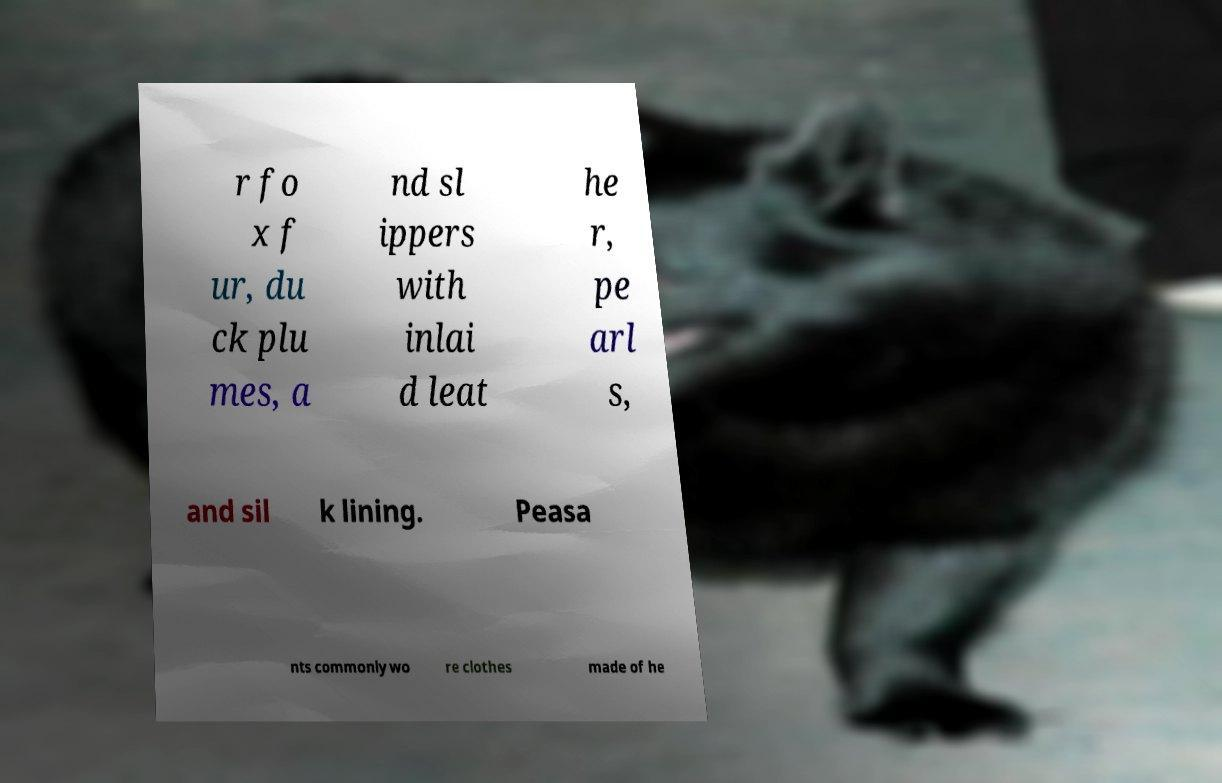Please identify and transcribe the text found in this image. r fo x f ur, du ck plu mes, a nd sl ippers with inlai d leat he r, pe arl s, and sil k lining. Peasa nts commonly wo re clothes made of he 